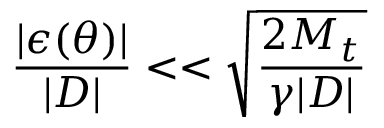Convert formula to latex. <formula><loc_0><loc_0><loc_500><loc_500>\frac { | \epsilon ( \theta ) | } { | D | } < < \sqrt { \frac { 2 M _ { t } } { \gamma | D | } }</formula> 